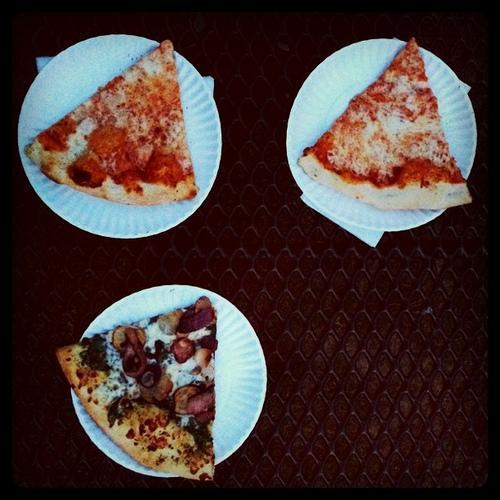How many plates?
Give a very brief answer. 3. 